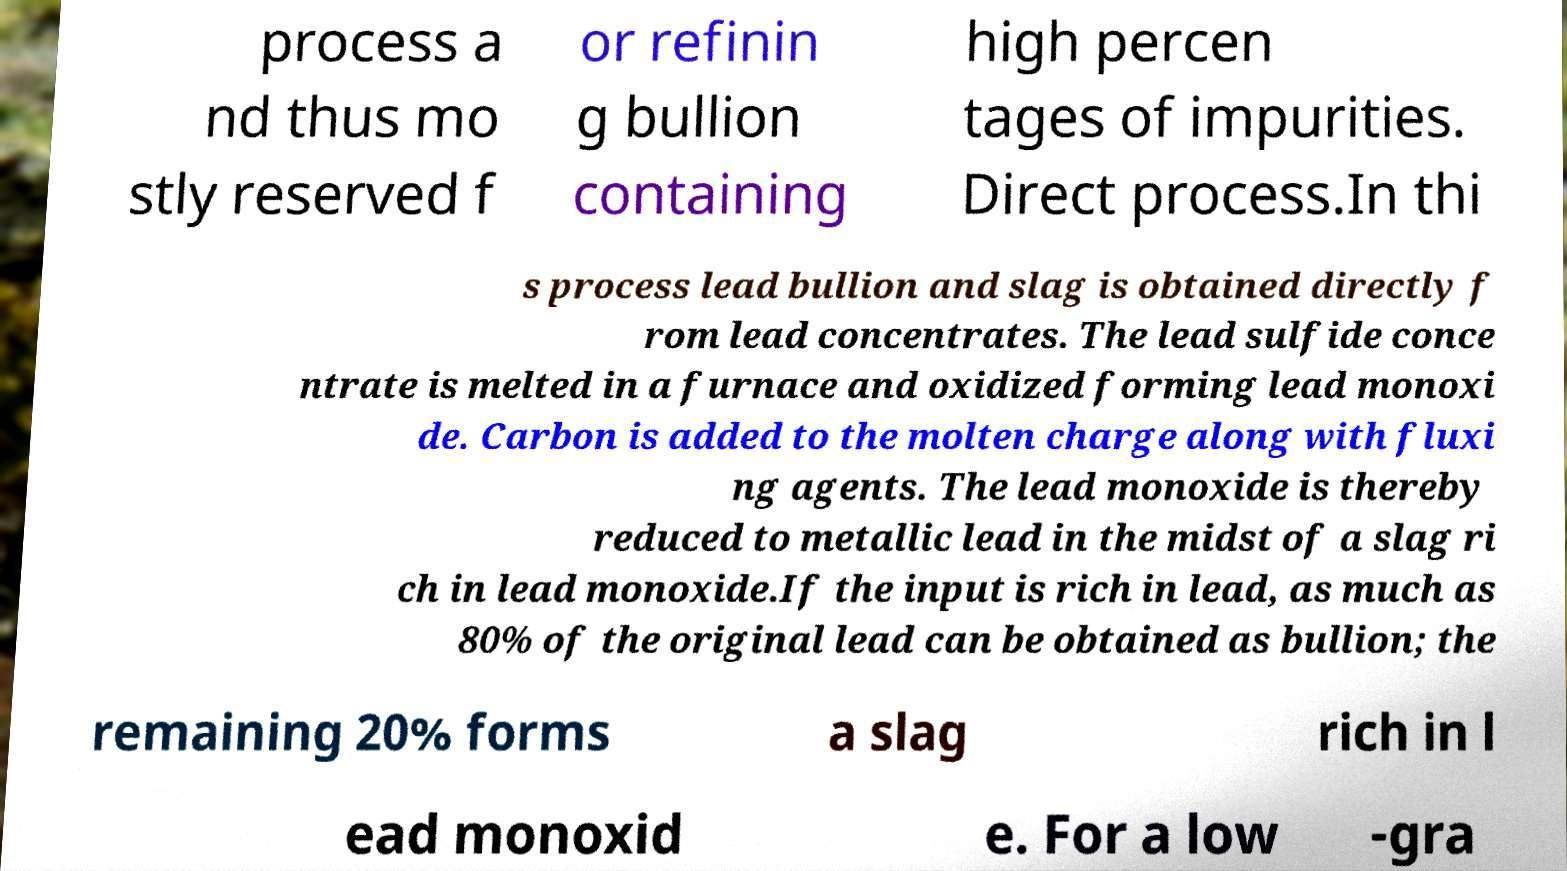Please read and relay the text visible in this image. What does it say? process a nd thus mo stly reserved f or refinin g bullion containing high percen tages of impurities. Direct process.In thi s process lead bullion and slag is obtained directly f rom lead concentrates. The lead sulfide conce ntrate is melted in a furnace and oxidized forming lead monoxi de. Carbon is added to the molten charge along with fluxi ng agents. The lead monoxide is thereby reduced to metallic lead in the midst of a slag ri ch in lead monoxide.If the input is rich in lead, as much as 80% of the original lead can be obtained as bullion; the remaining 20% forms a slag rich in l ead monoxid e. For a low -gra 